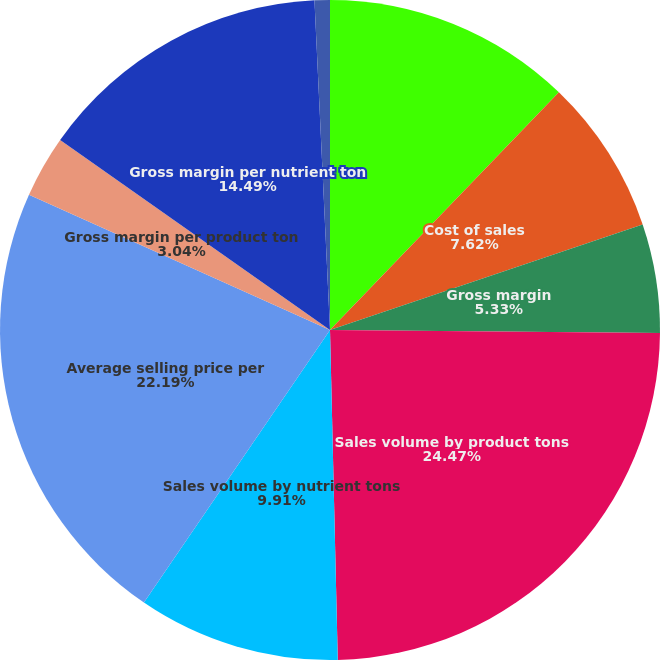Convert chart to OTSL. <chart><loc_0><loc_0><loc_500><loc_500><pie_chart><fcel>Net sales<fcel>Cost of sales<fcel>Gross margin<fcel>Sales volume by product tons<fcel>Sales volume by nutrient tons<fcel>Average selling price per<fcel>Gross margin per product ton<fcel>Gross margin per nutrient ton<fcel>Depreciation and amortization<nl><fcel>12.2%<fcel>7.62%<fcel>5.33%<fcel>24.48%<fcel>9.91%<fcel>22.19%<fcel>3.04%<fcel>14.49%<fcel>0.75%<nl></chart> 